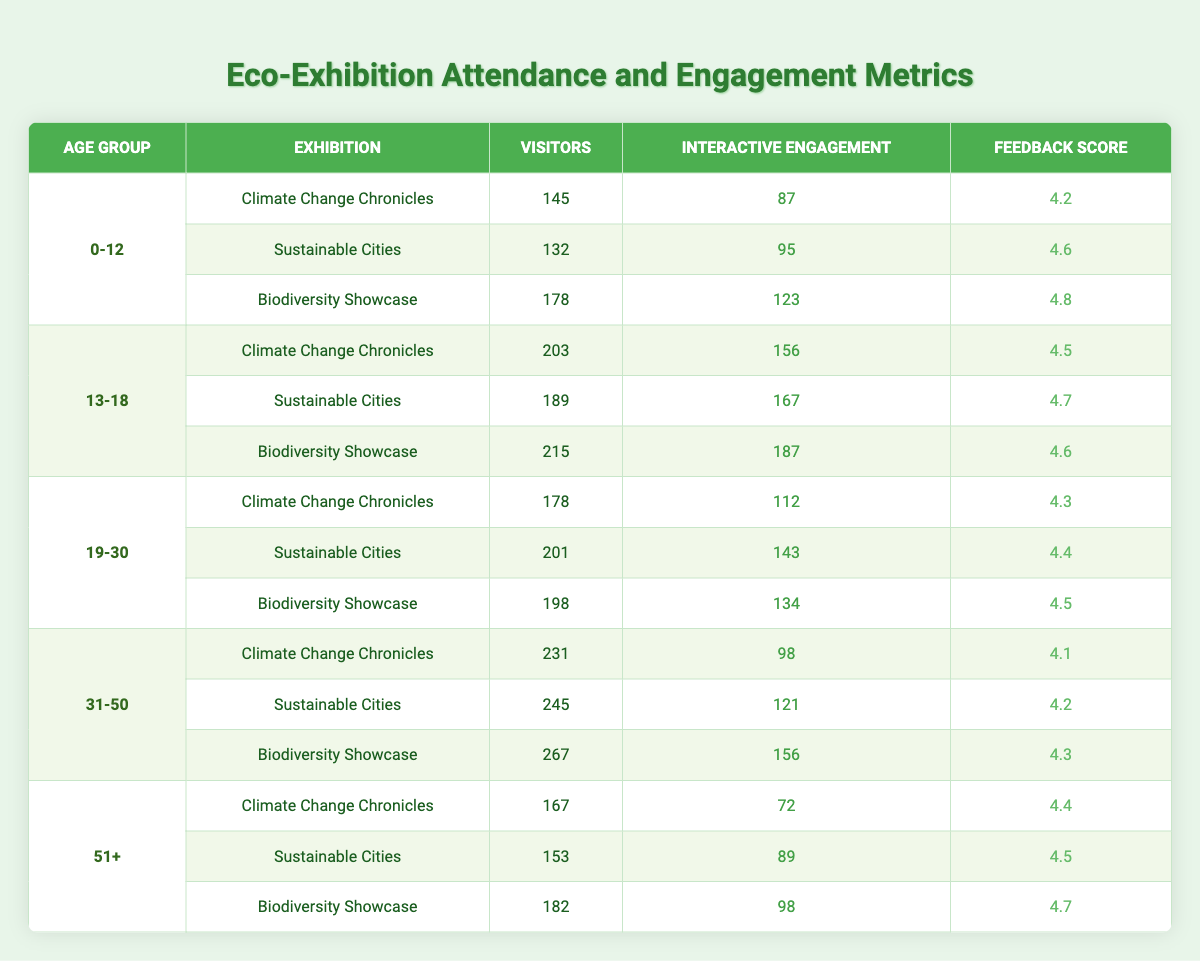What is the total number of visitors for the "Biodiversity Showcase" exhibition? By looking at the "Biodiversity Showcase" row for each age group, we have: 178 (0-12) + 215 (13-18) + 198 (19-30) + 267 (31-50) + 182 (51+) = 1040.
Answer: 1040 Which age group had the highest feedback score at the "Sustainable Cities" exhibition? In the "Sustainable Cities" exhibition, the feedback scores for each age group are: 4.6 (0-12), 4.7 (13-18), 4.4 (19-30), 4.2 (31-50), and 4.5 (51+). The highest score is 4.7 for the 13-18 age group.
Answer: 13-18 How many interactive engagements did the "Climate Change Chronicles" exhibition receive from the 31-50 age group? The "Climate Change Chronicles" exhibition for the 31-50 age group has an interactive engagement count of 98 as stated in the table.
Answer: 98 What is the average feedback score across all age groups for the "Biodiversity Showcase"? The feedback scores for the "Biodiversity Showcase" are: 4.8 (0-12), 4.6 (13-18), 4.5 (19-30), 4.3 (31-50), and 4.7 (51+). Summing these scores gives us 4.8 + 4.6 + 4.5 + 4.3 + 4.7 = 23.9. The average score is 23.9 / 5 = 4.78.
Answer: 4.78 Did the 51+ age group have more visitors at the "Sustainable Cities" than at "Climate Change Chronicles"? The "Sustainable Cities" exhibition had 153 visitors from the 51+ age group, while the "Climate Change Chronicles" had 167 visitors. Thus, no, they did not have more visitors at "Sustainable Cities".
Answer: No Which exhibition had the highest number of visitors overall? The total visitors per exhibition are: "Climate Change Chronicles" = 145 + 203 + 178 + 231 + 167 = 1024, "Sustainable Cities" = 132 + 189 + 201 + 245 + 153 = 1020, and "Biodiversity Showcase" = 178 + 215 + 198 + 267 + 182 = 1040. The highest is "Biodiversity Showcase" with 1040 visitors.
Answer: Biodiversity Showcase How many interactive engagements did the 0-12 age group record for all exhibitions combined? For the 0-12 age group, the totals from each exhibition are: 87 (Climate Change Chronicles) + 95 (Sustainable Cities) + 123 (Biodiversity Showcase) = 305.
Answer: 305 Is the feedback score for the 19-30 age group higher in "Biodiversity Showcase" than in "Sustainable Cities"? In "Biodiversity Showcase" the score is 4.5, while in "Sustainable Cities" it is 4.4. Since 4.5 is greater than 4.4, the statement is true.
Answer: Yes 